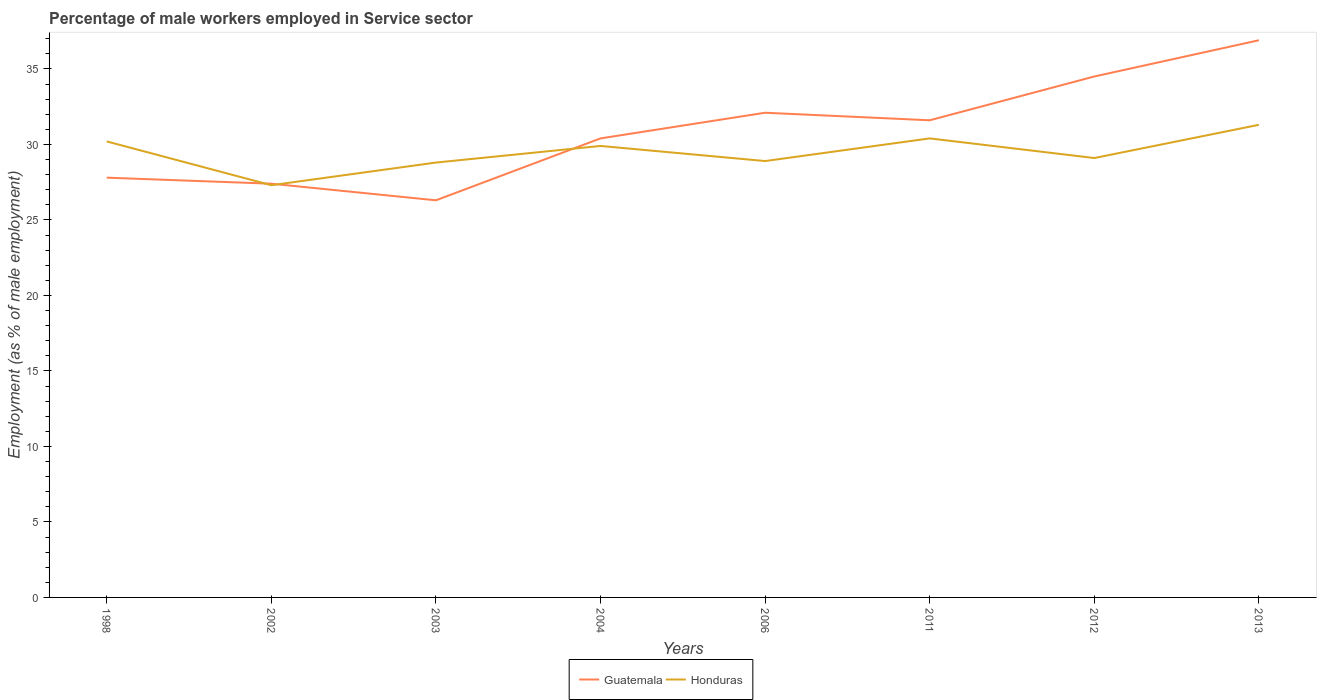How many different coloured lines are there?
Provide a succinct answer. 2. Does the line corresponding to Honduras intersect with the line corresponding to Guatemala?
Offer a very short reply. Yes. Is the number of lines equal to the number of legend labels?
Provide a short and direct response. Yes. Across all years, what is the maximum percentage of male workers employed in Service sector in Honduras?
Offer a very short reply. 27.3. In which year was the percentage of male workers employed in Service sector in Guatemala maximum?
Offer a very short reply. 2003. What is the total percentage of male workers employed in Service sector in Guatemala in the graph?
Ensure brevity in your answer.  -9.5. What is the difference between the highest and the second highest percentage of male workers employed in Service sector in Guatemala?
Make the answer very short. 10.6. Is the percentage of male workers employed in Service sector in Honduras strictly greater than the percentage of male workers employed in Service sector in Guatemala over the years?
Keep it short and to the point. No. How many lines are there?
Give a very brief answer. 2. How many years are there in the graph?
Offer a terse response. 8. What is the difference between two consecutive major ticks on the Y-axis?
Provide a succinct answer. 5. Are the values on the major ticks of Y-axis written in scientific E-notation?
Keep it short and to the point. No. Where does the legend appear in the graph?
Make the answer very short. Bottom center. How are the legend labels stacked?
Your response must be concise. Horizontal. What is the title of the graph?
Provide a short and direct response. Percentage of male workers employed in Service sector. Does "Cabo Verde" appear as one of the legend labels in the graph?
Ensure brevity in your answer.  No. What is the label or title of the X-axis?
Make the answer very short. Years. What is the label or title of the Y-axis?
Offer a terse response. Employment (as % of male employment). What is the Employment (as % of male employment) of Guatemala in 1998?
Offer a very short reply. 27.8. What is the Employment (as % of male employment) in Honduras in 1998?
Your answer should be compact. 30.2. What is the Employment (as % of male employment) of Guatemala in 2002?
Offer a very short reply. 27.4. What is the Employment (as % of male employment) of Honduras in 2002?
Provide a succinct answer. 27.3. What is the Employment (as % of male employment) of Guatemala in 2003?
Ensure brevity in your answer.  26.3. What is the Employment (as % of male employment) in Honduras in 2003?
Offer a terse response. 28.8. What is the Employment (as % of male employment) in Guatemala in 2004?
Your answer should be very brief. 30.4. What is the Employment (as % of male employment) in Honduras in 2004?
Your answer should be very brief. 29.9. What is the Employment (as % of male employment) in Guatemala in 2006?
Make the answer very short. 32.1. What is the Employment (as % of male employment) in Honduras in 2006?
Offer a terse response. 28.9. What is the Employment (as % of male employment) in Guatemala in 2011?
Offer a terse response. 31.6. What is the Employment (as % of male employment) in Honduras in 2011?
Your response must be concise. 30.4. What is the Employment (as % of male employment) in Guatemala in 2012?
Offer a terse response. 34.5. What is the Employment (as % of male employment) of Honduras in 2012?
Offer a very short reply. 29.1. What is the Employment (as % of male employment) of Guatemala in 2013?
Provide a short and direct response. 36.9. What is the Employment (as % of male employment) of Honduras in 2013?
Keep it short and to the point. 31.3. Across all years, what is the maximum Employment (as % of male employment) of Guatemala?
Ensure brevity in your answer.  36.9. Across all years, what is the maximum Employment (as % of male employment) of Honduras?
Provide a succinct answer. 31.3. Across all years, what is the minimum Employment (as % of male employment) in Guatemala?
Provide a short and direct response. 26.3. Across all years, what is the minimum Employment (as % of male employment) of Honduras?
Ensure brevity in your answer.  27.3. What is the total Employment (as % of male employment) of Guatemala in the graph?
Ensure brevity in your answer.  247. What is the total Employment (as % of male employment) in Honduras in the graph?
Provide a succinct answer. 235.9. What is the difference between the Employment (as % of male employment) in Honduras in 1998 and that in 2002?
Your response must be concise. 2.9. What is the difference between the Employment (as % of male employment) of Honduras in 1998 and that in 2003?
Keep it short and to the point. 1.4. What is the difference between the Employment (as % of male employment) of Guatemala in 1998 and that in 2011?
Your answer should be very brief. -3.8. What is the difference between the Employment (as % of male employment) of Honduras in 1998 and that in 2011?
Offer a very short reply. -0.2. What is the difference between the Employment (as % of male employment) of Guatemala in 1998 and that in 2012?
Keep it short and to the point. -6.7. What is the difference between the Employment (as % of male employment) in Honduras in 1998 and that in 2013?
Keep it short and to the point. -1.1. What is the difference between the Employment (as % of male employment) in Guatemala in 2002 and that in 2004?
Give a very brief answer. -3. What is the difference between the Employment (as % of male employment) of Guatemala in 2002 and that in 2006?
Provide a short and direct response. -4.7. What is the difference between the Employment (as % of male employment) in Honduras in 2002 and that in 2006?
Your answer should be compact. -1.6. What is the difference between the Employment (as % of male employment) of Guatemala in 2002 and that in 2011?
Your answer should be very brief. -4.2. What is the difference between the Employment (as % of male employment) of Guatemala in 2002 and that in 2012?
Offer a very short reply. -7.1. What is the difference between the Employment (as % of male employment) of Guatemala in 2003 and that in 2004?
Ensure brevity in your answer.  -4.1. What is the difference between the Employment (as % of male employment) of Honduras in 2003 and that in 2004?
Your response must be concise. -1.1. What is the difference between the Employment (as % of male employment) in Guatemala in 2003 and that in 2011?
Ensure brevity in your answer.  -5.3. What is the difference between the Employment (as % of male employment) of Honduras in 2003 and that in 2011?
Ensure brevity in your answer.  -1.6. What is the difference between the Employment (as % of male employment) in Guatemala in 2003 and that in 2012?
Provide a succinct answer. -8.2. What is the difference between the Employment (as % of male employment) of Honduras in 2003 and that in 2012?
Provide a short and direct response. -0.3. What is the difference between the Employment (as % of male employment) in Honduras in 2003 and that in 2013?
Offer a terse response. -2.5. What is the difference between the Employment (as % of male employment) in Guatemala in 2004 and that in 2006?
Offer a terse response. -1.7. What is the difference between the Employment (as % of male employment) in Honduras in 2004 and that in 2006?
Make the answer very short. 1. What is the difference between the Employment (as % of male employment) of Guatemala in 2004 and that in 2011?
Your answer should be very brief. -1.2. What is the difference between the Employment (as % of male employment) of Honduras in 2004 and that in 2011?
Offer a very short reply. -0.5. What is the difference between the Employment (as % of male employment) of Guatemala in 2004 and that in 2012?
Ensure brevity in your answer.  -4.1. What is the difference between the Employment (as % of male employment) of Guatemala in 2006 and that in 2011?
Provide a short and direct response. 0.5. What is the difference between the Employment (as % of male employment) of Honduras in 2006 and that in 2011?
Offer a very short reply. -1.5. What is the difference between the Employment (as % of male employment) in Guatemala in 2006 and that in 2013?
Provide a short and direct response. -4.8. What is the difference between the Employment (as % of male employment) in Honduras in 2006 and that in 2013?
Keep it short and to the point. -2.4. What is the difference between the Employment (as % of male employment) in Guatemala in 2011 and that in 2012?
Keep it short and to the point. -2.9. What is the difference between the Employment (as % of male employment) of Honduras in 2011 and that in 2012?
Keep it short and to the point. 1.3. What is the difference between the Employment (as % of male employment) in Guatemala in 2012 and that in 2013?
Provide a short and direct response. -2.4. What is the difference between the Employment (as % of male employment) of Guatemala in 1998 and the Employment (as % of male employment) of Honduras in 2002?
Your answer should be very brief. 0.5. What is the difference between the Employment (as % of male employment) in Guatemala in 1998 and the Employment (as % of male employment) in Honduras in 2004?
Offer a very short reply. -2.1. What is the difference between the Employment (as % of male employment) in Guatemala in 1998 and the Employment (as % of male employment) in Honduras in 2006?
Give a very brief answer. -1.1. What is the difference between the Employment (as % of male employment) of Guatemala in 1998 and the Employment (as % of male employment) of Honduras in 2011?
Offer a terse response. -2.6. What is the difference between the Employment (as % of male employment) in Guatemala in 1998 and the Employment (as % of male employment) in Honduras in 2012?
Keep it short and to the point. -1.3. What is the difference between the Employment (as % of male employment) of Guatemala in 2002 and the Employment (as % of male employment) of Honduras in 2004?
Give a very brief answer. -2.5. What is the difference between the Employment (as % of male employment) of Guatemala in 2002 and the Employment (as % of male employment) of Honduras in 2006?
Provide a succinct answer. -1.5. What is the difference between the Employment (as % of male employment) in Guatemala in 2002 and the Employment (as % of male employment) in Honduras in 2012?
Offer a terse response. -1.7. What is the difference between the Employment (as % of male employment) in Guatemala in 2003 and the Employment (as % of male employment) in Honduras in 2011?
Provide a short and direct response. -4.1. What is the difference between the Employment (as % of male employment) in Guatemala in 2003 and the Employment (as % of male employment) in Honduras in 2013?
Keep it short and to the point. -5. What is the difference between the Employment (as % of male employment) in Guatemala in 2004 and the Employment (as % of male employment) in Honduras in 2012?
Provide a succinct answer. 1.3. What is the difference between the Employment (as % of male employment) of Guatemala in 2006 and the Employment (as % of male employment) of Honduras in 2012?
Keep it short and to the point. 3. What is the difference between the Employment (as % of male employment) in Guatemala in 2011 and the Employment (as % of male employment) in Honduras in 2012?
Your response must be concise. 2.5. What is the average Employment (as % of male employment) of Guatemala per year?
Provide a succinct answer. 30.88. What is the average Employment (as % of male employment) in Honduras per year?
Ensure brevity in your answer.  29.49. In the year 2003, what is the difference between the Employment (as % of male employment) in Guatemala and Employment (as % of male employment) in Honduras?
Give a very brief answer. -2.5. In the year 2006, what is the difference between the Employment (as % of male employment) of Guatemala and Employment (as % of male employment) of Honduras?
Provide a short and direct response. 3.2. In the year 2011, what is the difference between the Employment (as % of male employment) in Guatemala and Employment (as % of male employment) in Honduras?
Offer a terse response. 1.2. In the year 2012, what is the difference between the Employment (as % of male employment) in Guatemala and Employment (as % of male employment) in Honduras?
Offer a terse response. 5.4. In the year 2013, what is the difference between the Employment (as % of male employment) of Guatemala and Employment (as % of male employment) of Honduras?
Give a very brief answer. 5.6. What is the ratio of the Employment (as % of male employment) of Guatemala in 1998 to that in 2002?
Keep it short and to the point. 1.01. What is the ratio of the Employment (as % of male employment) in Honduras in 1998 to that in 2002?
Keep it short and to the point. 1.11. What is the ratio of the Employment (as % of male employment) of Guatemala in 1998 to that in 2003?
Provide a succinct answer. 1.06. What is the ratio of the Employment (as % of male employment) in Honduras in 1998 to that in 2003?
Your answer should be compact. 1.05. What is the ratio of the Employment (as % of male employment) in Guatemala in 1998 to that in 2004?
Offer a very short reply. 0.91. What is the ratio of the Employment (as % of male employment) of Guatemala in 1998 to that in 2006?
Your answer should be very brief. 0.87. What is the ratio of the Employment (as % of male employment) of Honduras in 1998 to that in 2006?
Give a very brief answer. 1.04. What is the ratio of the Employment (as % of male employment) in Guatemala in 1998 to that in 2011?
Your response must be concise. 0.88. What is the ratio of the Employment (as % of male employment) in Honduras in 1998 to that in 2011?
Your answer should be very brief. 0.99. What is the ratio of the Employment (as % of male employment) in Guatemala in 1998 to that in 2012?
Offer a terse response. 0.81. What is the ratio of the Employment (as % of male employment) in Honduras in 1998 to that in 2012?
Make the answer very short. 1.04. What is the ratio of the Employment (as % of male employment) of Guatemala in 1998 to that in 2013?
Provide a short and direct response. 0.75. What is the ratio of the Employment (as % of male employment) of Honduras in 1998 to that in 2013?
Offer a very short reply. 0.96. What is the ratio of the Employment (as % of male employment) of Guatemala in 2002 to that in 2003?
Make the answer very short. 1.04. What is the ratio of the Employment (as % of male employment) in Honduras in 2002 to that in 2003?
Make the answer very short. 0.95. What is the ratio of the Employment (as % of male employment) in Guatemala in 2002 to that in 2004?
Your answer should be very brief. 0.9. What is the ratio of the Employment (as % of male employment) of Honduras in 2002 to that in 2004?
Your answer should be compact. 0.91. What is the ratio of the Employment (as % of male employment) of Guatemala in 2002 to that in 2006?
Offer a terse response. 0.85. What is the ratio of the Employment (as % of male employment) of Honduras in 2002 to that in 2006?
Provide a succinct answer. 0.94. What is the ratio of the Employment (as % of male employment) in Guatemala in 2002 to that in 2011?
Your response must be concise. 0.87. What is the ratio of the Employment (as % of male employment) of Honduras in 2002 to that in 2011?
Your answer should be compact. 0.9. What is the ratio of the Employment (as % of male employment) of Guatemala in 2002 to that in 2012?
Your answer should be compact. 0.79. What is the ratio of the Employment (as % of male employment) of Honduras in 2002 to that in 2012?
Provide a short and direct response. 0.94. What is the ratio of the Employment (as % of male employment) of Guatemala in 2002 to that in 2013?
Your answer should be very brief. 0.74. What is the ratio of the Employment (as % of male employment) of Honduras in 2002 to that in 2013?
Your response must be concise. 0.87. What is the ratio of the Employment (as % of male employment) of Guatemala in 2003 to that in 2004?
Ensure brevity in your answer.  0.87. What is the ratio of the Employment (as % of male employment) of Honduras in 2003 to that in 2004?
Keep it short and to the point. 0.96. What is the ratio of the Employment (as % of male employment) of Guatemala in 2003 to that in 2006?
Provide a short and direct response. 0.82. What is the ratio of the Employment (as % of male employment) of Guatemala in 2003 to that in 2011?
Your answer should be compact. 0.83. What is the ratio of the Employment (as % of male employment) of Guatemala in 2003 to that in 2012?
Your answer should be compact. 0.76. What is the ratio of the Employment (as % of male employment) in Guatemala in 2003 to that in 2013?
Keep it short and to the point. 0.71. What is the ratio of the Employment (as % of male employment) in Honduras in 2003 to that in 2013?
Your response must be concise. 0.92. What is the ratio of the Employment (as % of male employment) of Guatemala in 2004 to that in 2006?
Keep it short and to the point. 0.95. What is the ratio of the Employment (as % of male employment) in Honduras in 2004 to that in 2006?
Your response must be concise. 1.03. What is the ratio of the Employment (as % of male employment) in Honduras in 2004 to that in 2011?
Provide a succinct answer. 0.98. What is the ratio of the Employment (as % of male employment) of Guatemala in 2004 to that in 2012?
Give a very brief answer. 0.88. What is the ratio of the Employment (as % of male employment) in Honduras in 2004 to that in 2012?
Offer a terse response. 1.03. What is the ratio of the Employment (as % of male employment) of Guatemala in 2004 to that in 2013?
Give a very brief answer. 0.82. What is the ratio of the Employment (as % of male employment) of Honduras in 2004 to that in 2013?
Your response must be concise. 0.96. What is the ratio of the Employment (as % of male employment) of Guatemala in 2006 to that in 2011?
Your answer should be compact. 1.02. What is the ratio of the Employment (as % of male employment) of Honduras in 2006 to that in 2011?
Your response must be concise. 0.95. What is the ratio of the Employment (as % of male employment) in Guatemala in 2006 to that in 2012?
Offer a terse response. 0.93. What is the ratio of the Employment (as % of male employment) in Honduras in 2006 to that in 2012?
Ensure brevity in your answer.  0.99. What is the ratio of the Employment (as % of male employment) of Guatemala in 2006 to that in 2013?
Your answer should be very brief. 0.87. What is the ratio of the Employment (as % of male employment) of Honduras in 2006 to that in 2013?
Your answer should be compact. 0.92. What is the ratio of the Employment (as % of male employment) of Guatemala in 2011 to that in 2012?
Give a very brief answer. 0.92. What is the ratio of the Employment (as % of male employment) of Honduras in 2011 to that in 2012?
Provide a succinct answer. 1.04. What is the ratio of the Employment (as % of male employment) in Guatemala in 2011 to that in 2013?
Your answer should be very brief. 0.86. What is the ratio of the Employment (as % of male employment) in Honduras in 2011 to that in 2013?
Give a very brief answer. 0.97. What is the ratio of the Employment (as % of male employment) in Guatemala in 2012 to that in 2013?
Your answer should be very brief. 0.94. What is the ratio of the Employment (as % of male employment) of Honduras in 2012 to that in 2013?
Your response must be concise. 0.93. What is the difference between the highest and the second highest Employment (as % of male employment) in Guatemala?
Your response must be concise. 2.4. What is the difference between the highest and the second highest Employment (as % of male employment) of Honduras?
Ensure brevity in your answer.  0.9. What is the difference between the highest and the lowest Employment (as % of male employment) in Honduras?
Provide a succinct answer. 4. 